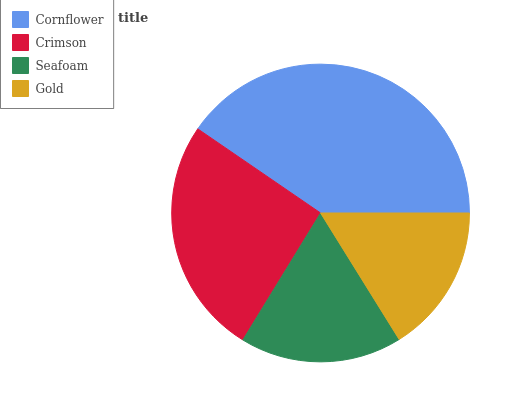Is Gold the minimum?
Answer yes or no. Yes. Is Cornflower the maximum?
Answer yes or no. Yes. Is Crimson the minimum?
Answer yes or no. No. Is Crimson the maximum?
Answer yes or no. No. Is Cornflower greater than Crimson?
Answer yes or no. Yes. Is Crimson less than Cornflower?
Answer yes or no. Yes. Is Crimson greater than Cornflower?
Answer yes or no. No. Is Cornflower less than Crimson?
Answer yes or no. No. Is Crimson the high median?
Answer yes or no. Yes. Is Seafoam the low median?
Answer yes or no. Yes. Is Seafoam the high median?
Answer yes or no. No. Is Gold the low median?
Answer yes or no. No. 